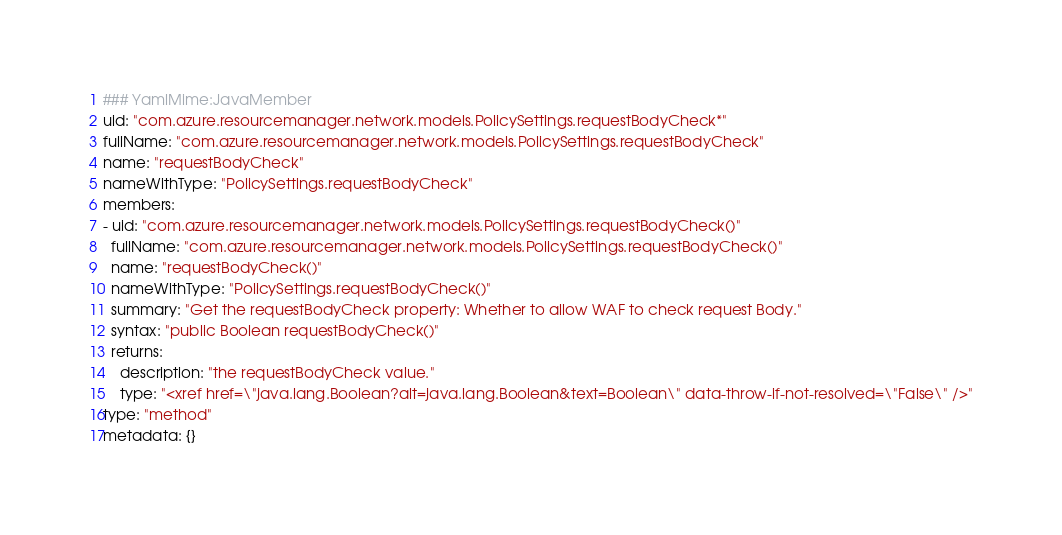Convert code to text. <code><loc_0><loc_0><loc_500><loc_500><_YAML_>### YamlMime:JavaMember
uid: "com.azure.resourcemanager.network.models.PolicySettings.requestBodyCheck*"
fullName: "com.azure.resourcemanager.network.models.PolicySettings.requestBodyCheck"
name: "requestBodyCheck"
nameWithType: "PolicySettings.requestBodyCheck"
members:
- uid: "com.azure.resourcemanager.network.models.PolicySettings.requestBodyCheck()"
  fullName: "com.azure.resourcemanager.network.models.PolicySettings.requestBodyCheck()"
  name: "requestBodyCheck()"
  nameWithType: "PolicySettings.requestBodyCheck()"
  summary: "Get the requestBodyCheck property: Whether to allow WAF to check request Body."
  syntax: "public Boolean requestBodyCheck()"
  returns:
    description: "the requestBodyCheck value."
    type: "<xref href=\"java.lang.Boolean?alt=java.lang.Boolean&text=Boolean\" data-throw-if-not-resolved=\"False\" />"
type: "method"
metadata: {}</code> 